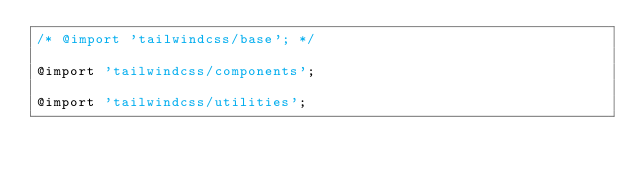Convert code to text. <code><loc_0><loc_0><loc_500><loc_500><_CSS_>/* @import 'tailwindcss/base'; */

@import 'tailwindcss/components';

@import 'tailwindcss/utilities';
</code> 